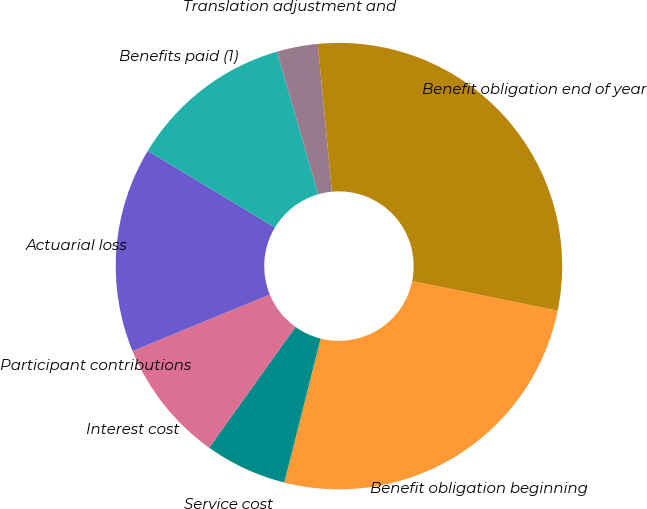Convert chart to OTSL. <chart><loc_0><loc_0><loc_500><loc_500><pie_chart><fcel>Benefit obligation beginning<fcel>Service cost<fcel>Interest cost<fcel>Participant contributions<fcel>Actuarial loss<fcel>Benefits paid (1)<fcel>Translation adjustment and<fcel>Benefit obligation end of year<nl><fcel>25.74%<fcel>5.94%<fcel>8.91%<fcel>0.0%<fcel>14.85%<fcel>11.88%<fcel>2.97%<fcel>29.7%<nl></chart> 